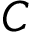Convert formula to latex. <formula><loc_0><loc_0><loc_500><loc_500>C</formula> 